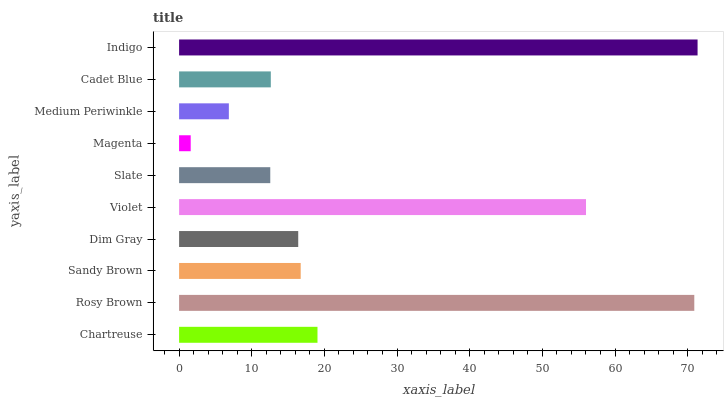Is Magenta the minimum?
Answer yes or no. Yes. Is Indigo the maximum?
Answer yes or no. Yes. Is Rosy Brown the minimum?
Answer yes or no. No. Is Rosy Brown the maximum?
Answer yes or no. No. Is Rosy Brown greater than Chartreuse?
Answer yes or no. Yes. Is Chartreuse less than Rosy Brown?
Answer yes or no. Yes. Is Chartreuse greater than Rosy Brown?
Answer yes or no. No. Is Rosy Brown less than Chartreuse?
Answer yes or no. No. Is Sandy Brown the high median?
Answer yes or no. Yes. Is Dim Gray the low median?
Answer yes or no. Yes. Is Dim Gray the high median?
Answer yes or no. No. Is Rosy Brown the low median?
Answer yes or no. No. 